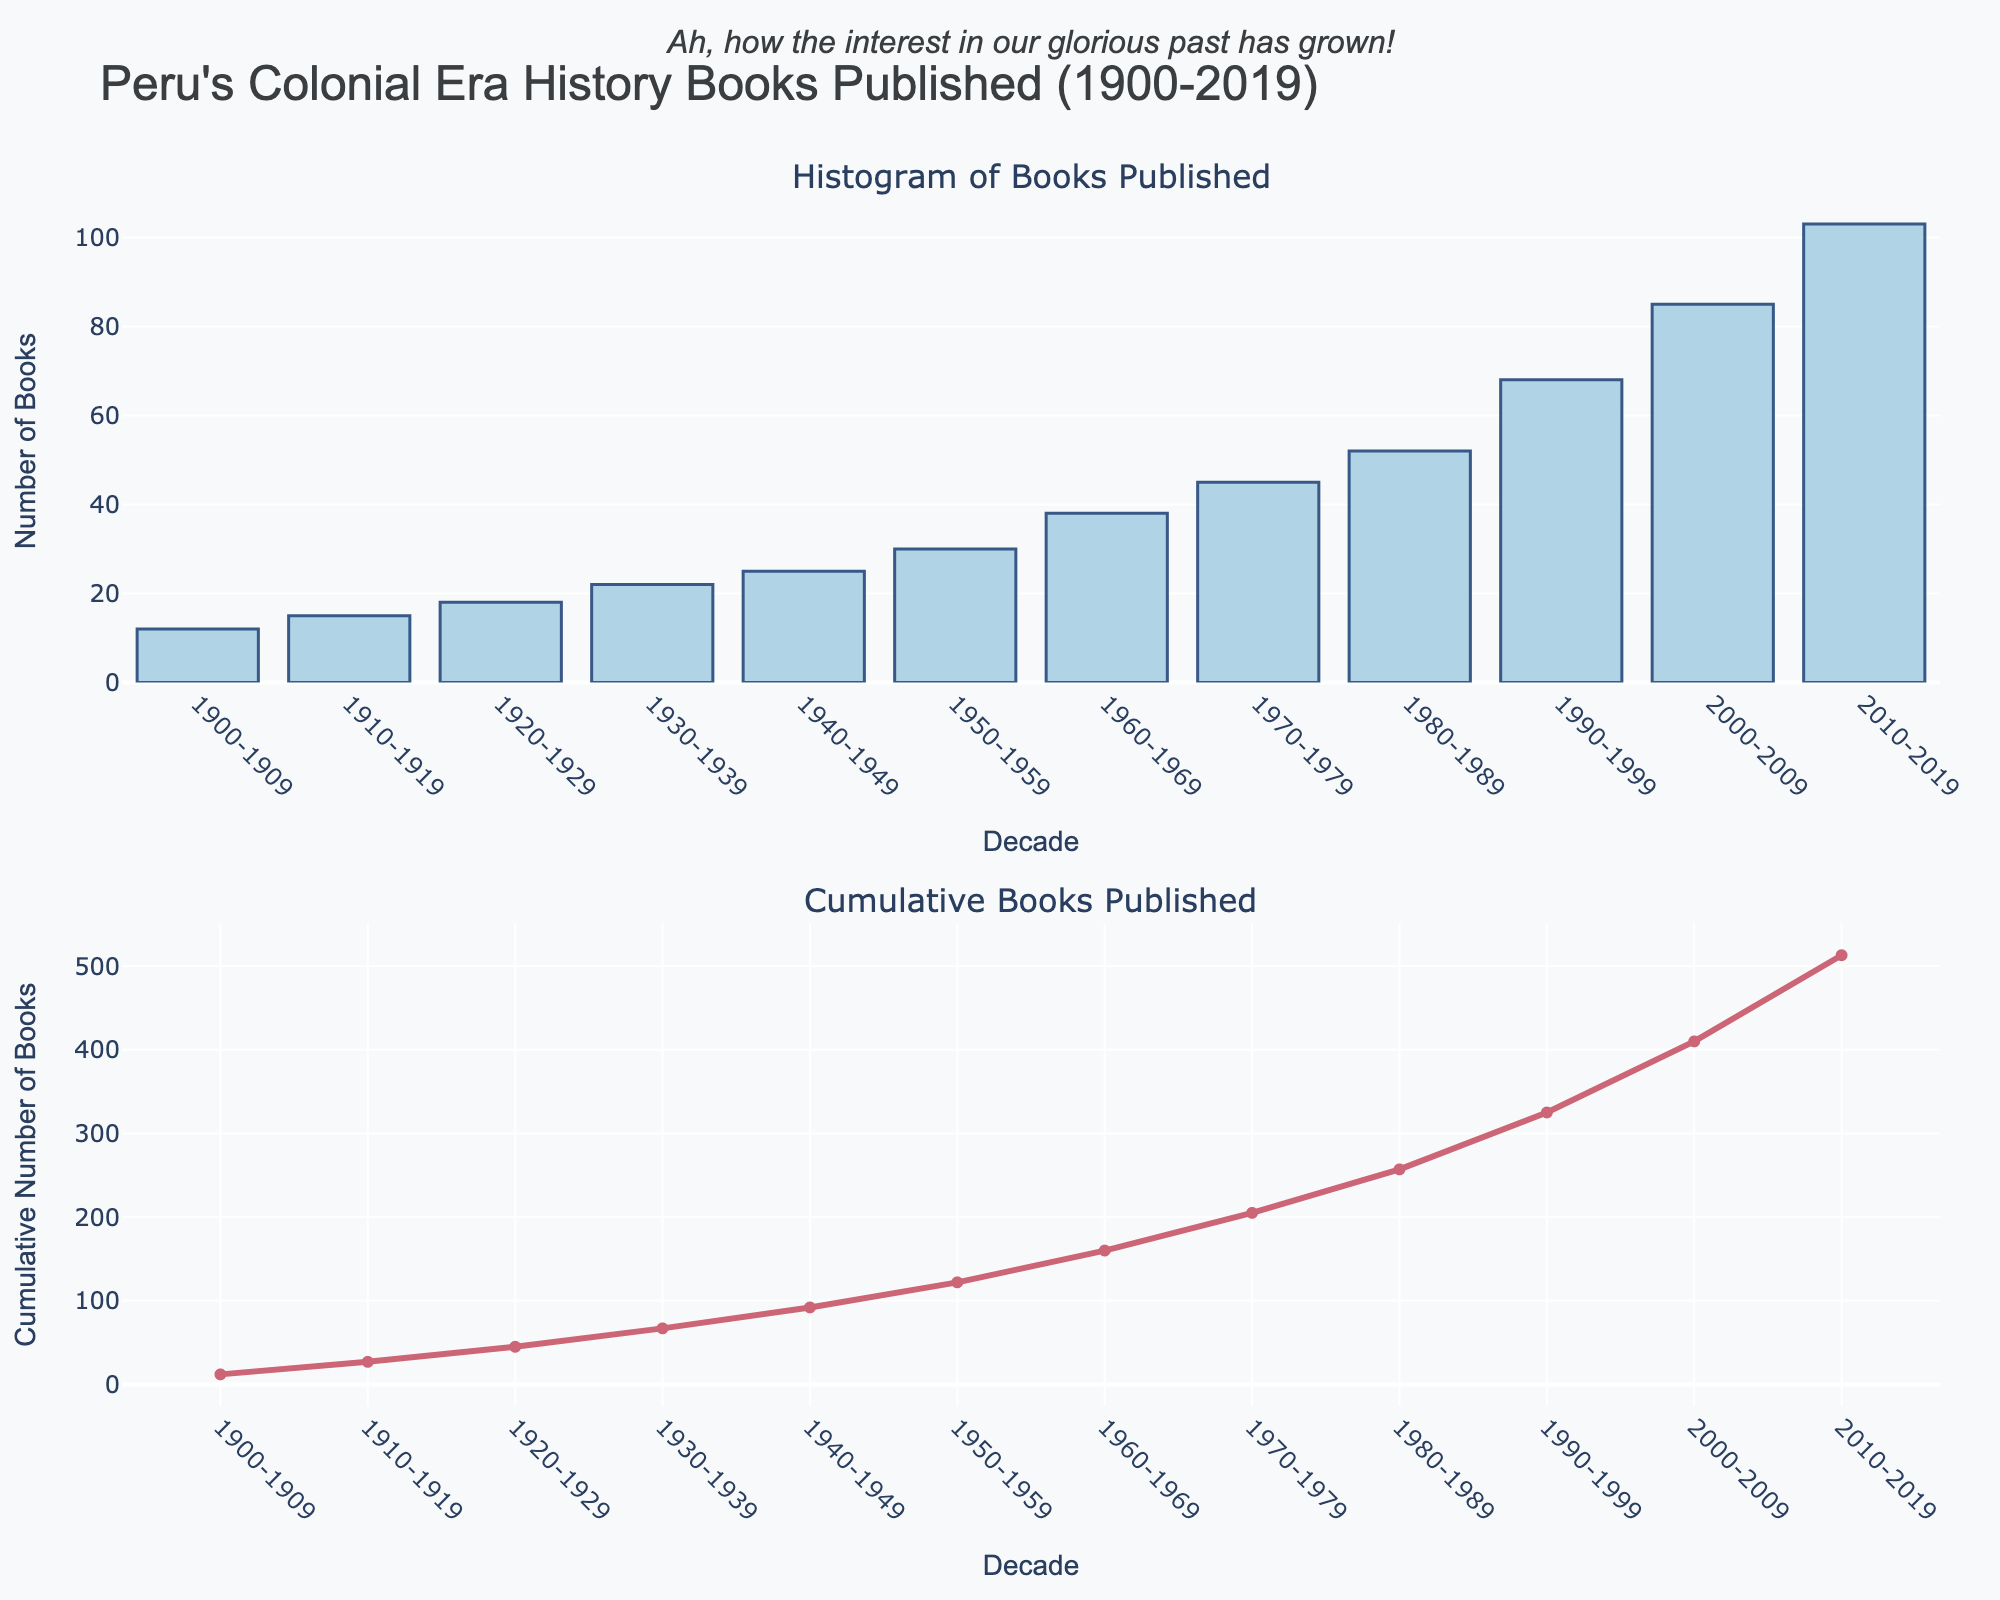What's the title of the plot? The title is located at the top center of the figure. The text reads "Peru's Colonial Era History Books Published (1900-2019)."
Answer: "Peru's Colonial Era History Books Published (1900-2019)" What does the first subplot represent? The first subplot is the histogram showing the number of history books published about Peru's colonial era per decade from 1900 to 2019.
Answer: Number of history books published per decade What trend is observed in the number of books published from 1900 to 2019? The histogram shows an increasing trend in the number of books published over each decade from 1900 to 2019. This is indicated by the increasing heights of the bars.
Answer: An increasing trend Which decade had the highest number of books published? In the first subplot, the tallest bar represents the decade with the highest number of books published. This is the decade 2010-2019.
Answer: 2010-2019 How many books were published in the decade 1930-1939? Referring to the bar for the decade "1930-1939" in the histogram, the label indicates that 22 books were published.
Answer: 22 What is the cumulative number of books published up to 1969? We need to add the number of books published per decade up to 1969: 12 + 15 + 18 + 22 + 25 + 30 + 38. The cumulative total is 160.
Answer: 160 Between which two consecutive decades was the largest increase in the number of books published observed? We compare the height of each bar between consecutive decades to find the largest increase. The largest increase is from 2000-2009 to 2010-2019, which is 103 - 85 = 18 books.
Answer: 2000-2009 to 2010-2019 What is the cumulative number of books published by the end of 1999? Sum the number of books for each decade from 1900-1999: 12 + 15 + 18 + 22 + 25 + 30 + 38 + 45 + 52 + 68 = 325. The cumulative total is 325.
Answer: 325 Compare the number of books published in 1960-1969 and 1970-1979. Which decade had more books published and by how many? The number of books published in 1960-1969 is 38, and in 1970-1979 is 45. The difference is 45 - 38 = 7 books. Therefore, 1970-1979 had more books published by 7 books.
Answer: 1970-1979, 7 books How does the cumulative graph in the second subplot help in understanding the overall trend of book publications? The cumulative graph in the second subplot shows the total number of books published up to each decade, offering a visual representation of how interest has grown over time. It provides insight into the overall increase in publications, not just decade-specific data.
Answer: It shows the overall growth trend 